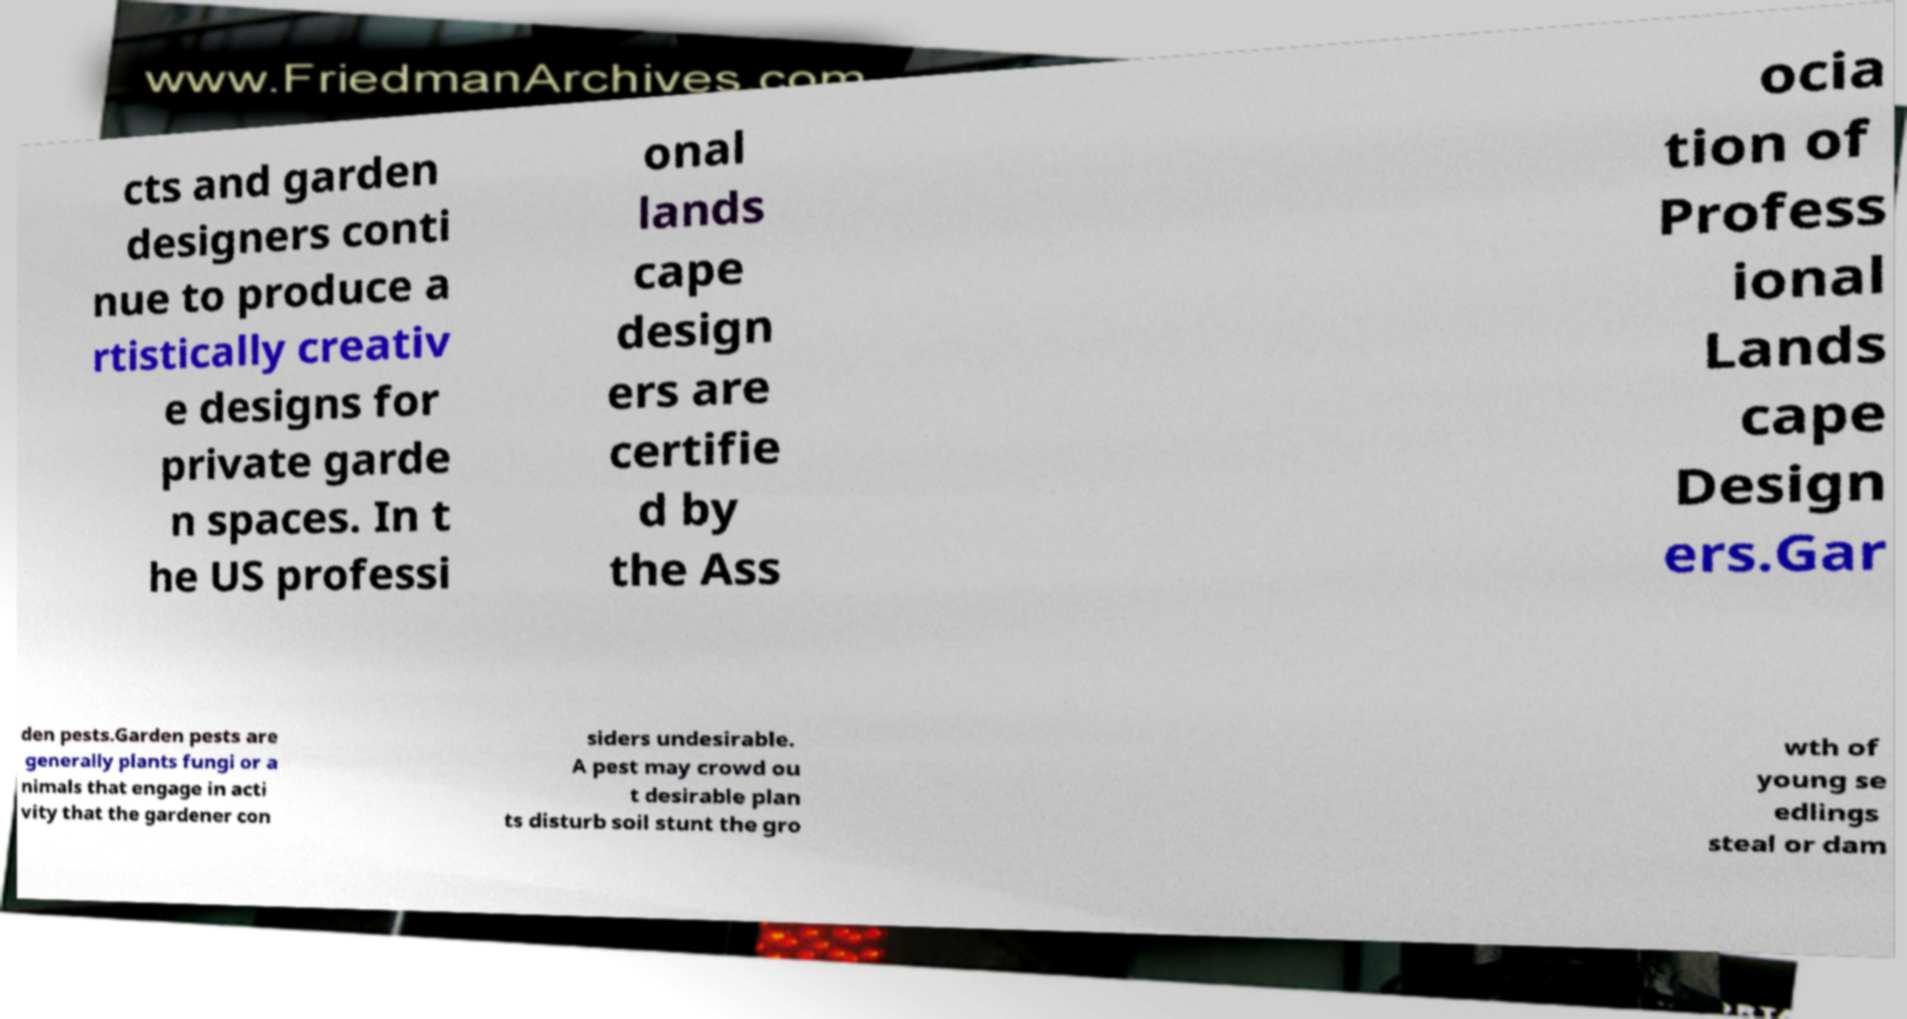Can you read and provide the text displayed in the image?This photo seems to have some interesting text. Can you extract and type it out for me? cts and garden designers conti nue to produce a rtistically creativ e designs for private garde n spaces. In t he US professi onal lands cape design ers are certifie d by the Ass ocia tion of Profess ional Lands cape Design ers.Gar den pests.Garden pests are generally plants fungi or a nimals that engage in acti vity that the gardener con siders undesirable. A pest may crowd ou t desirable plan ts disturb soil stunt the gro wth of young se edlings steal or dam 